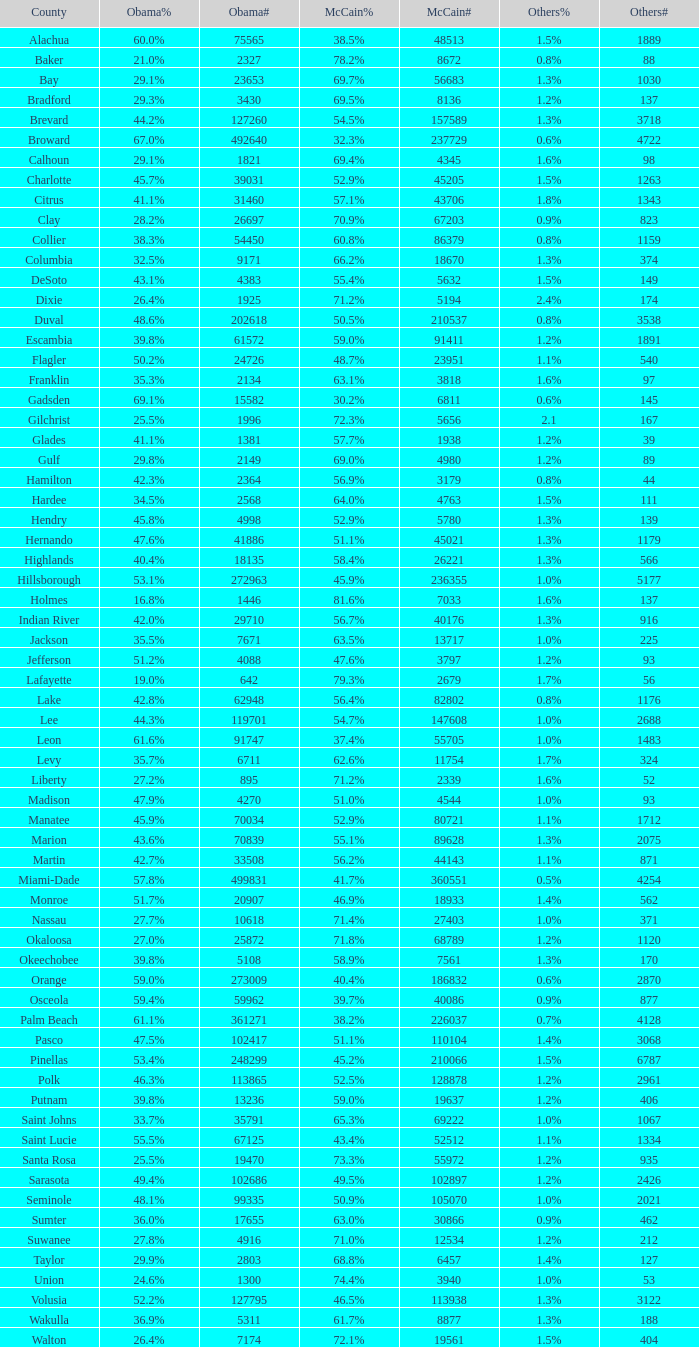What was the total of voters backing mccain when obama secured 895? 2339.0. 